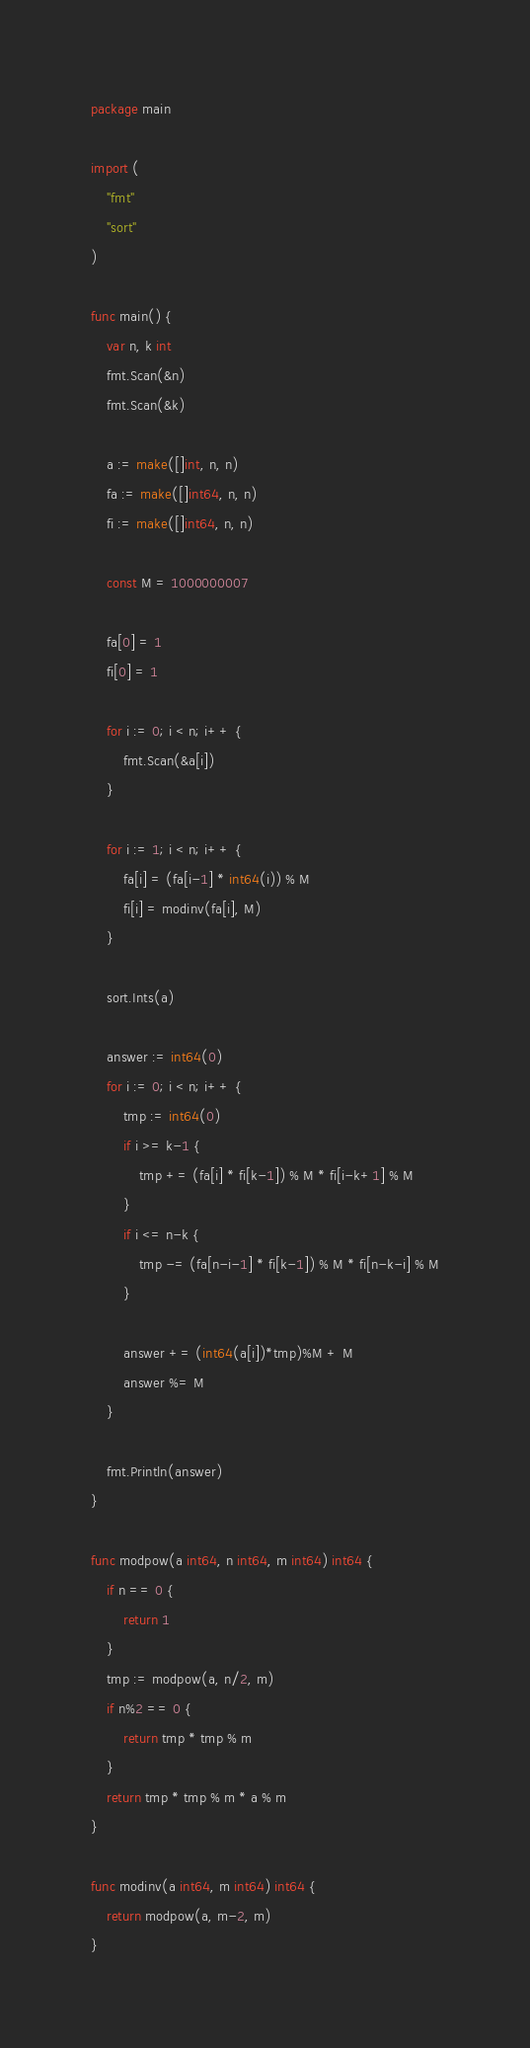Convert code to text. <code><loc_0><loc_0><loc_500><loc_500><_Go_>package main

import (
	"fmt"
	"sort"
)

func main() {
	var n, k int
	fmt.Scan(&n)
	fmt.Scan(&k)

	a := make([]int, n, n)
	fa := make([]int64, n, n)
	fi := make([]int64, n, n)

	const M = 1000000007

	fa[0] = 1
	fi[0] = 1

	for i := 0; i < n; i++ {
		fmt.Scan(&a[i])
	}

	for i := 1; i < n; i++ {
		fa[i] = (fa[i-1] * int64(i)) % M
		fi[i] = modinv(fa[i], M)
	}

	sort.Ints(a)

	answer := int64(0)
	for i := 0; i < n; i++ {
		tmp := int64(0)
		if i >= k-1 {
			tmp += (fa[i] * fi[k-1]) % M * fi[i-k+1] % M
		}
		if i <= n-k {
			tmp -= (fa[n-i-1] * fi[k-1]) % M * fi[n-k-i] % M
		}

		answer += (int64(a[i])*tmp)%M + M
		answer %= M
	}

	fmt.Println(answer)
}

func modpow(a int64, n int64, m int64) int64 {
	if n == 0 {
		return 1
	}
	tmp := modpow(a, n/2, m)
	if n%2 == 0 {
		return tmp * tmp % m
	}
	return tmp * tmp % m * a % m
}

func modinv(a int64, m int64) int64 {
	return modpow(a, m-2, m)
}
</code> 